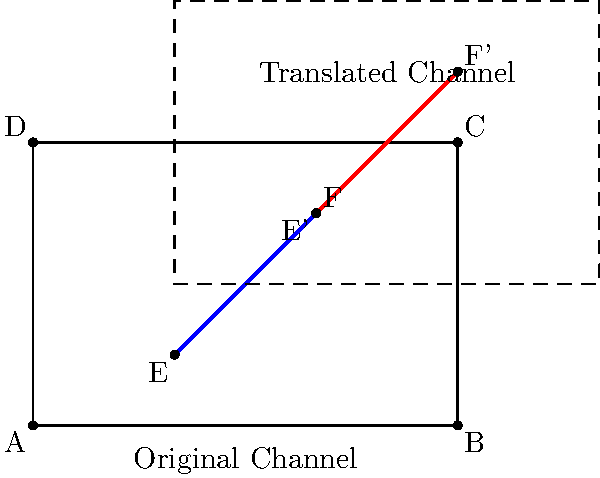In a nautical chart, two buoys mark a safe channel for ships to navigate. The original positions of the buoys are at points E(2,1) and F(4,3). To accommodate a new underwater obstacle, the channel needs to be shifted 2 units to the right and 2 units up. What are the new coordinates of the buoys after this translation? To solve this problem, we'll follow these steps:

1) The translation is 2 units right and 2 units up. This can be represented as a vector $(2,2)$.

2) To translate a point, we add the translation vector to the original coordinates.

3) For point E(2,1):
   New x-coordinate: $2 + 2 = 4$
   New y-coordinate: $1 + 2 = 3$
   So, E' = (4,3)

4) For point F(4,3):
   New x-coordinate: $4 + 2 = 6$
   New y-coordinate: $3 + 2 = 5$
   So, F' = (6,5)

5) Therefore, after translation, the new coordinates of the buoys are E'(4,3) and F'(6,5).

This translation ensures that the safe channel maintains its shape and orientation while shifting to avoid the new underwater obstacle.
Answer: E'(4,3) and F'(6,5) 